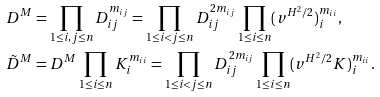<formula> <loc_0><loc_0><loc_500><loc_500>D ^ { M } & = \prod _ { 1 \leq i , j \leq n } D _ { i j } ^ { m _ { i j } } = \prod _ { 1 \leq i < j \leq n } D _ { i j } ^ { 2 m _ { i j } } \prod _ { 1 \leq i \leq n } ( v ^ { H ^ { 2 } / 2 } ) _ { i } ^ { m _ { i i } } , \\ \tilde { D } ^ { M } & = D ^ { M } \prod _ { 1 \leq i \leq n } K _ { i } ^ { m _ { i i } } = \prod _ { 1 \leq i < j \leq n } D _ { i j } ^ { 2 m _ { i j } } \prod _ { 1 \leq i \leq n } ( v ^ { H ^ { 2 } / 2 } K ) _ { i } ^ { m _ { i i } } .</formula> 